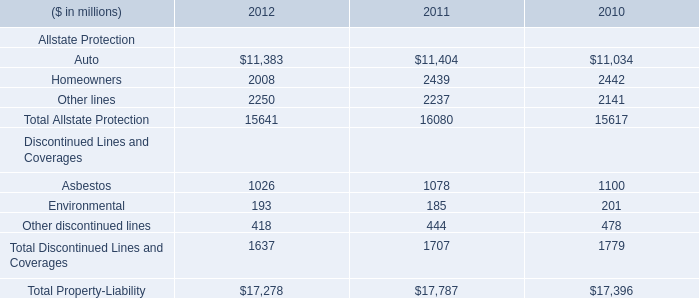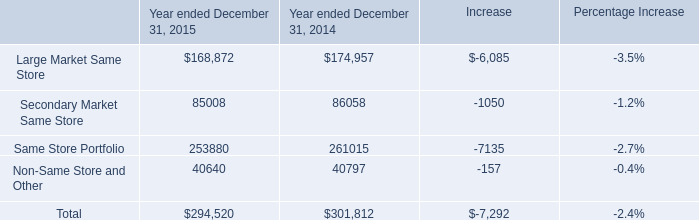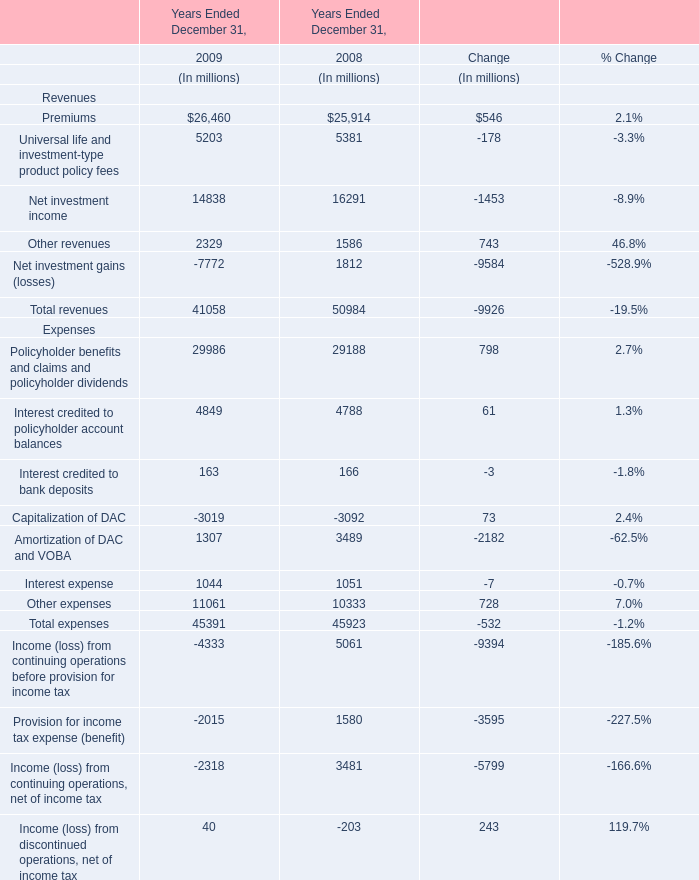What is the sum of Premiums for Revenues in 2008 and Other lines for Allstate Protection in 2011? (in million) 
Computations: (25914 + 2237)
Answer: 28151.0. 